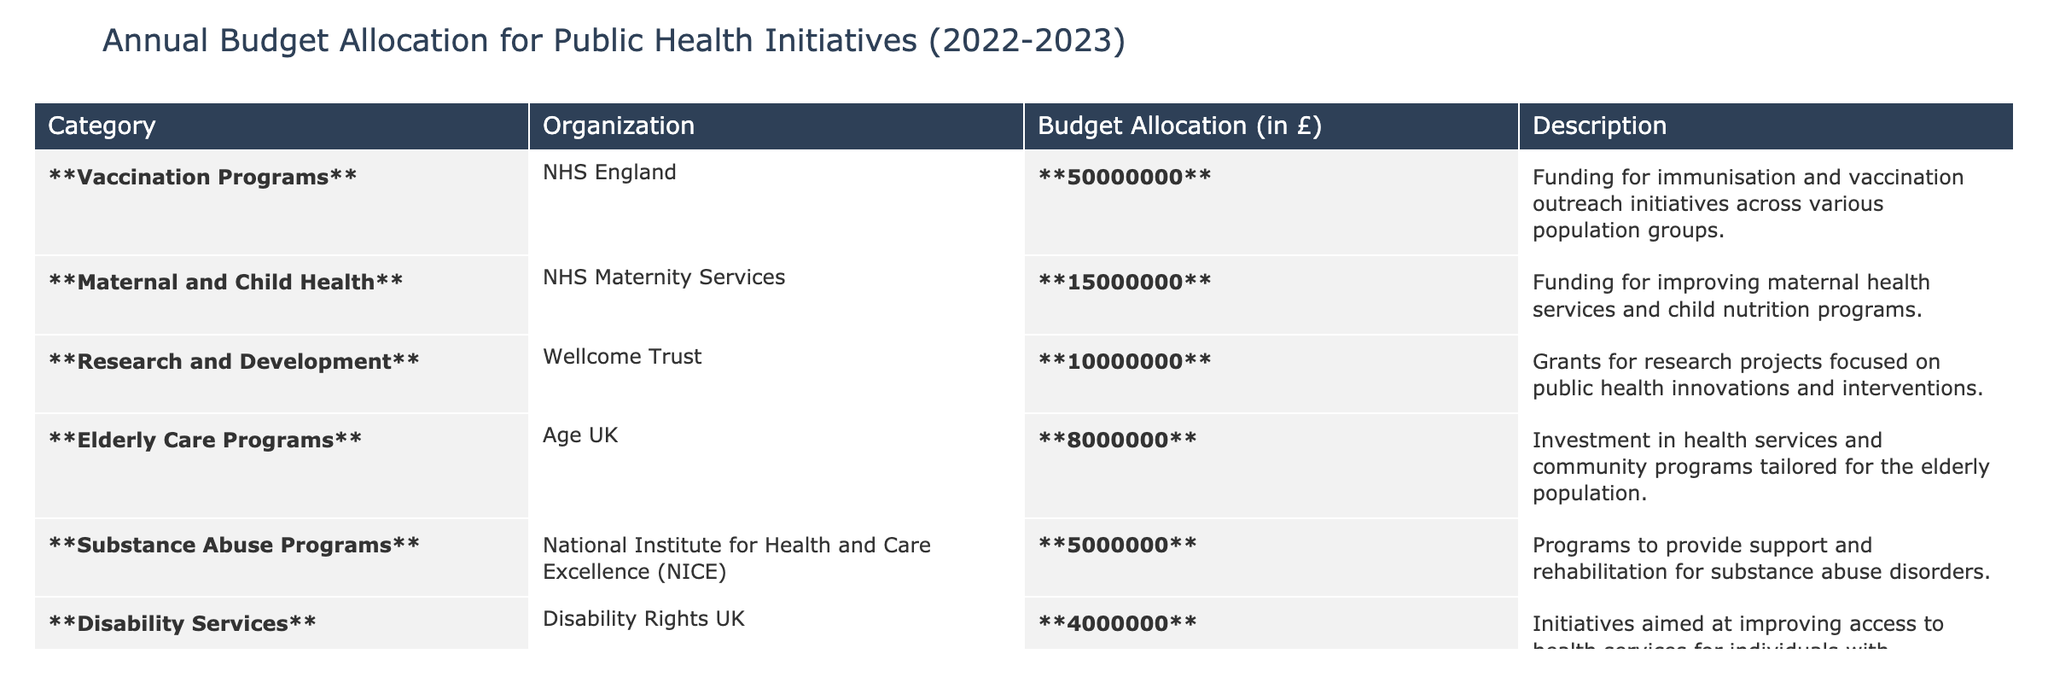What is the total budget allocated for Vaccination Programs? The table states that the budget allocation for Vaccination Programs is **£50,000,000**.
Answer: £50,000,000 Which organization received the lowest budget allocation? From the table, Disability Rights UK has the lowest budget allocation of **£4,000,000** compared to others.
Answer: Disability Rights UK What is the combined budget for Maternal and Child Health and Elderly Care Programs? The budget for Maternal and Child Health is **£15,000,000** and for Elderly Care Programs is **£8,000,000**, totaling **£15,000,000 + £8,000,000 = £23,000,000**.
Answer: £23,000,000 Is the budget for Research and Development greater than the budget for Substance Abuse Programs? The budget for Research and Development is **£10,000,000** and for Substance Abuse Programs is **£5,000,000**, and **£10,000,000 > £5,000,000**.
Answer: Yes What percentage of the total budget does the funding for Vaccination Programs represent? The total budget is **£50,000,000 + £15,000,000 + £10,000,000 + £8,000,000 + £5,000,000 + £4,000,000 = £92,000,000**. The percentage for Vaccination Programs is **(50,000,000 / 92,000,000) * 100 ≈ 54.35%**.
Answer: 54.35% What is the difference between the budget allocations for Disability Services and Substance Abuse Programs? Disability Services received **£4,000,000** while Substance Abuse Programs received **£5,000,000**, hence the difference is **£5,000,000 - £4,000,000 = £1,000,000**.
Answer: £1,000,000 If you combine the budgets for all programs except for Research and Development, what is the total? The total for the other programs is **£50,000,000 + £15,000,000 + £8,000,000 + £5,000,000 + £4,000,000 = £82,000,000**.
Answer: £82,000,000 Are there any programs that received a budget allocation of less than £6,000,000? From the data, Disability Services with **£4,000,000** and Substance Abuse Programs with **£5,000,000** both received less than **£6,000,000**.
Answer: Yes Which program has the largest budget allocation, and how much is it? The program with the largest budget allocation is Vaccination Programs with **£50,000,000**.
Answer: Vaccination Programs; £50,000,000 What is the average budget allocation across all organizations listed? The total budget is **£92,000,000** and there are 6 organizations, so the average allocation is **£92,000,000 / 6 ≈ £15,333,333.33**.
Answer: £15,333,333.33 